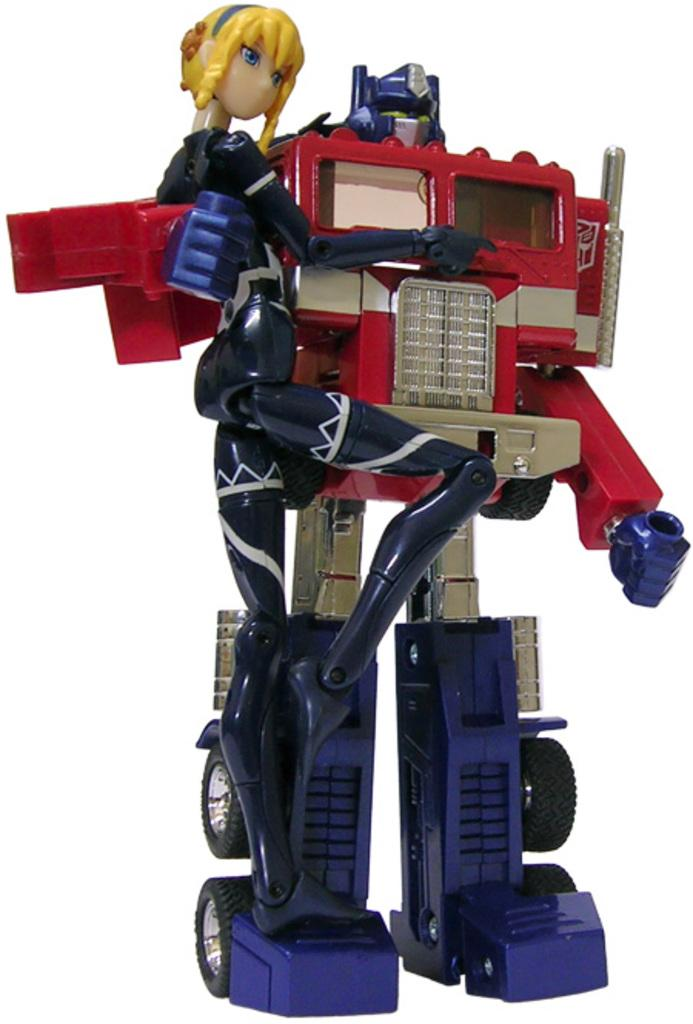What object in the image is designed for play or entertainment? There is a toy in the image. What type of haircut does the toy have in the image? There is no haircut present in the image, as the toy does not have hair. 